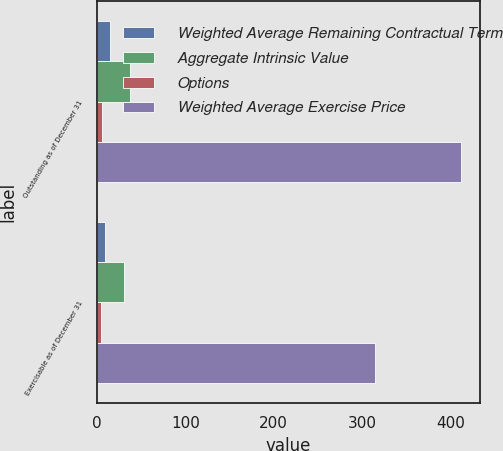Convert chart. <chart><loc_0><loc_0><loc_500><loc_500><stacked_bar_chart><ecel><fcel>Outstanding as of December 31<fcel>Exercisable as of December 31<nl><fcel>Weighted Average Remaining Contractual Term<fcel>14.7<fcel>8.8<nl><fcel>Aggregate Intrinsic Value<fcel>37.63<fcel>29.82<nl><fcel>Options<fcel>5.6<fcel>4<nl><fcel>Weighted Average Exercise Price<fcel>412.5<fcel>314.7<nl></chart> 